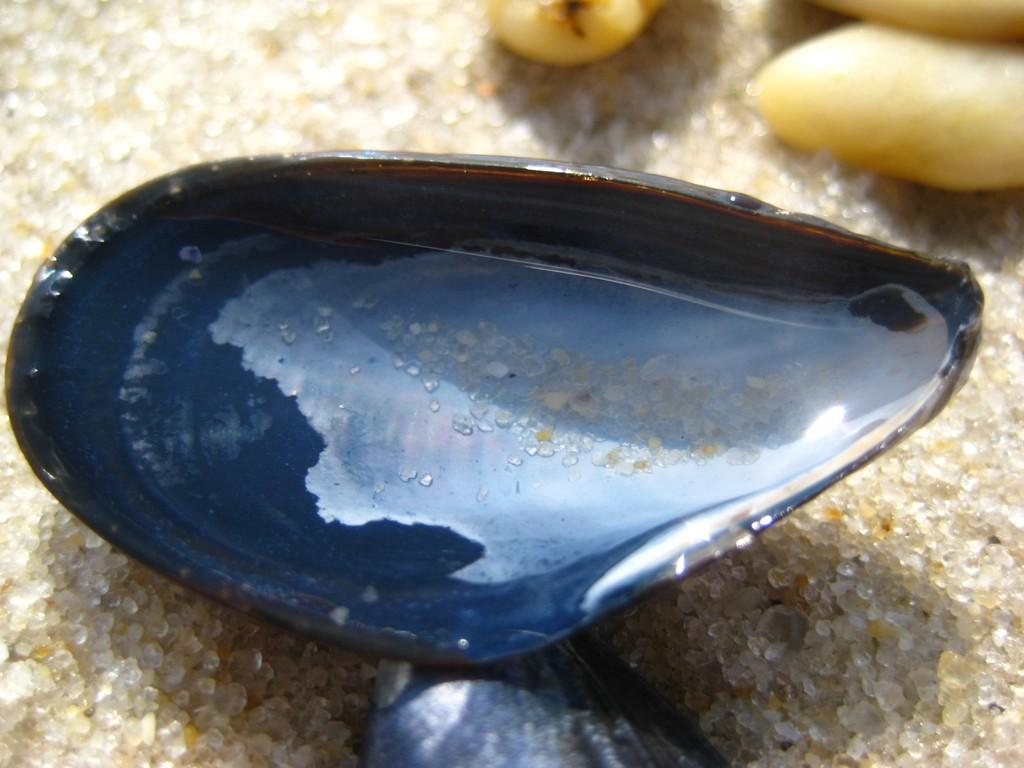What is the main object in the image? There is a shell in the image. What is inside the shell? The shell contains water. What other objects can be seen in the image? There are stones visible in the image. What type of surface is present in the image? The sand is visible in the image. What type of wine is being poured from the shell in the image? There is no wine present in the image; it features a shell containing water. How many ladybugs can be seen crawling on the stones in the image? There are no ladybugs present in the image; it only contains a shell, water, stones, and sand. 